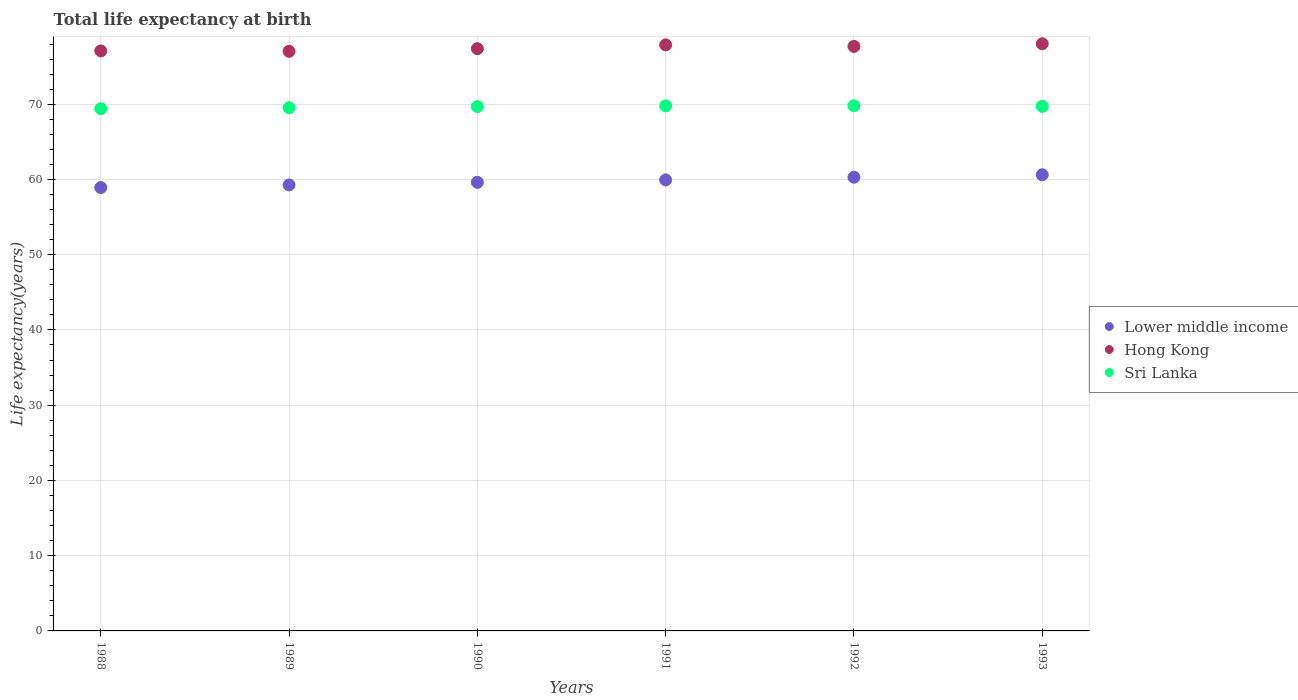Is the number of dotlines equal to the number of legend labels?
Provide a succinct answer. Yes. What is the life expectancy at birth in in Sri Lanka in 1990?
Your response must be concise. 69.68. Across all years, what is the maximum life expectancy at birth in in Hong Kong?
Keep it short and to the point. 78.03. Across all years, what is the minimum life expectancy at birth in in Hong Kong?
Your answer should be very brief. 77.03. In which year was the life expectancy at birth in in Sri Lanka maximum?
Your response must be concise. 1992. What is the total life expectancy at birth in in Lower middle income in the graph?
Your answer should be very brief. 358.67. What is the difference between the life expectancy at birth in in Lower middle income in 1989 and that in 1992?
Your response must be concise. -1.02. What is the difference between the life expectancy at birth in in Sri Lanka in 1991 and the life expectancy at birth in in Lower middle income in 1990?
Your answer should be compact. 10.16. What is the average life expectancy at birth in in Lower middle income per year?
Your answer should be very brief. 59.78. In the year 1988, what is the difference between the life expectancy at birth in in Sri Lanka and life expectancy at birth in in Hong Kong?
Make the answer very short. -7.68. What is the ratio of the life expectancy at birth in in Lower middle income in 1988 to that in 1992?
Ensure brevity in your answer.  0.98. What is the difference between the highest and the second highest life expectancy at birth in in Hong Kong?
Give a very brief answer. 0.15. What is the difference between the highest and the lowest life expectancy at birth in in Sri Lanka?
Offer a very short reply. 0.39. In how many years, is the life expectancy at birth in in Sri Lanka greater than the average life expectancy at birth in in Sri Lanka taken over all years?
Give a very brief answer. 4. Is the sum of the life expectancy at birth in in Hong Kong in 1989 and 1992 greater than the maximum life expectancy at birth in in Lower middle income across all years?
Give a very brief answer. Yes. Is it the case that in every year, the sum of the life expectancy at birth in in Hong Kong and life expectancy at birth in in Sri Lanka  is greater than the life expectancy at birth in in Lower middle income?
Your response must be concise. Yes. Does the life expectancy at birth in in Sri Lanka monotonically increase over the years?
Provide a succinct answer. No. Is the life expectancy at birth in in Sri Lanka strictly greater than the life expectancy at birth in in Lower middle income over the years?
Provide a short and direct response. Yes. Is the life expectancy at birth in in Hong Kong strictly less than the life expectancy at birth in in Sri Lanka over the years?
Your answer should be very brief. No. How many dotlines are there?
Keep it short and to the point. 3. How many years are there in the graph?
Your response must be concise. 6. Does the graph contain any zero values?
Offer a terse response. No. Does the graph contain grids?
Provide a short and direct response. Yes. How many legend labels are there?
Your answer should be compact. 3. What is the title of the graph?
Offer a very short reply. Total life expectancy at birth. Does "St. Martin (French part)" appear as one of the legend labels in the graph?
Your response must be concise. No. What is the label or title of the Y-axis?
Make the answer very short. Life expectancy(years). What is the Life expectancy(years) of Lower middle income in 1988?
Your response must be concise. 58.93. What is the Life expectancy(years) in Hong Kong in 1988?
Provide a short and direct response. 77.08. What is the Life expectancy(years) in Sri Lanka in 1988?
Make the answer very short. 69.4. What is the Life expectancy(years) of Lower middle income in 1989?
Ensure brevity in your answer.  59.27. What is the Life expectancy(years) in Hong Kong in 1989?
Your response must be concise. 77.03. What is the Life expectancy(years) in Sri Lanka in 1989?
Keep it short and to the point. 69.53. What is the Life expectancy(years) in Lower middle income in 1990?
Your answer should be very brief. 59.62. What is the Life expectancy(years) in Hong Kong in 1990?
Offer a terse response. 77.38. What is the Life expectancy(years) in Sri Lanka in 1990?
Make the answer very short. 69.68. What is the Life expectancy(years) of Lower middle income in 1991?
Your answer should be compact. 59.94. What is the Life expectancy(years) in Hong Kong in 1991?
Your answer should be very brief. 77.88. What is the Life expectancy(years) in Sri Lanka in 1991?
Make the answer very short. 69.78. What is the Life expectancy(years) in Lower middle income in 1992?
Your response must be concise. 60.29. What is the Life expectancy(years) of Hong Kong in 1992?
Offer a very short reply. 77.68. What is the Life expectancy(years) in Sri Lanka in 1992?
Your answer should be compact. 69.8. What is the Life expectancy(years) of Lower middle income in 1993?
Offer a very short reply. 60.62. What is the Life expectancy(years) in Hong Kong in 1993?
Make the answer very short. 78.03. What is the Life expectancy(years) in Sri Lanka in 1993?
Offer a very short reply. 69.72. Across all years, what is the maximum Life expectancy(years) in Lower middle income?
Offer a terse response. 60.62. Across all years, what is the maximum Life expectancy(years) of Hong Kong?
Your response must be concise. 78.03. Across all years, what is the maximum Life expectancy(years) in Sri Lanka?
Your answer should be compact. 69.8. Across all years, what is the minimum Life expectancy(years) in Lower middle income?
Make the answer very short. 58.93. Across all years, what is the minimum Life expectancy(years) of Hong Kong?
Provide a short and direct response. 77.03. Across all years, what is the minimum Life expectancy(years) in Sri Lanka?
Provide a short and direct response. 69.4. What is the total Life expectancy(years) of Lower middle income in the graph?
Offer a very short reply. 358.67. What is the total Life expectancy(years) in Hong Kong in the graph?
Keep it short and to the point. 465.09. What is the total Life expectancy(years) of Sri Lanka in the graph?
Your answer should be very brief. 417.91. What is the difference between the Life expectancy(years) of Lower middle income in 1988 and that in 1989?
Your response must be concise. -0.35. What is the difference between the Life expectancy(years) in Hong Kong in 1988 and that in 1989?
Keep it short and to the point. 0.05. What is the difference between the Life expectancy(years) in Sri Lanka in 1988 and that in 1989?
Provide a short and direct response. -0.13. What is the difference between the Life expectancy(years) in Lower middle income in 1988 and that in 1990?
Provide a succinct answer. -0.69. What is the difference between the Life expectancy(years) of Hong Kong in 1988 and that in 1990?
Provide a succinct answer. -0.3. What is the difference between the Life expectancy(years) of Sri Lanka in 1988 and that in 1990?
Ensure brevity in your answer.  -0.28. What is the difference between the Life expectancy(years) of Lower middle income in 1988 and that in 1991?
Your response must be concise. -1.01. What is the difference between the Life expectancy(years) of Sri Lanka in 1988 and that in 1991?
Your answer should be compact. -0.38. What is the difference between the Life expectancy(years) in Lower middle income in 1988 and that in 1992?
Ensure brevity in your answer.  -1.37. What is the difference between the Life expectancy(years) of Hong Kong in 1988 and that in 1992?
Make the answer very short. -0.6. What is the difference between the Life expectancy(years) in Sri Lanka in 1988 and that in 1992?
Ensure brevity in your answer.  -0.39. What is the difference between the Life expectancy(years) in Lower middle income in 1988 and that in 1993?
Your answer should be compact. -1.7. What is the difference between the Life expectancy(years) in Hong Kong in 1988 and that in 1993?
Your response must be concise. -0.95. What is the difference between the Life expectancy(years) of Sri Lanka in 1988 and that in 1993?
Offer a very short reply. -0.31. What is the difference between the Life expectancy(years) in Lower middle income in 1989 and that in 1990?
Make the answer very short. -0.34. What is the difference between the Life expectancy(years) in Hong Kong in 1989 and that in 1990?
Keep it short and to the point. -0.35. What is the difference between the Life expectancy(years) of Sri Lanka in 1989 and that in 1990?
Your answer should be compact. -0.15. What is the difference between the Life expectancy(years) in Lower middle income in 1989 and that in 1991?
Make the answer very short. -0.66. What is the difference between the Life expectancy(years) of Hong Kong in 1989 and that in 1991?
Offer a terse response. -0.85. What is the difference between the Life expectancy(years) in Sri Lanka in 1989 and that in 1991?
Your response must be concise. -0.25. What is the difference between the Life expectancy(years) of Lower middle income in 1989 and that in 1992?
Keep it short and to the point. -1.02. What is the difference between the Life expectancy(years) in Hong Kong in 1989 and that in 1992?
Offer a very short reply. -0.65. What is the difference between the Life expectancy(years) in Sri Lanka in 1989 and that in 1992?
Provide a short and direct response. -0.26. What is the difference between the Life expectancy(years) of Lower middle income in 1989 and that in 1993?
Ensure brevity in your answer.  -1.35. What is the difference between the Life expectancy(years) in Hong Kong in 1989 and that in 1993?
Offer a terse response. -1. What is the difference between the Life expectancy(years) in Sri Lanka in 1989 and that in 1993?
Offer a very short reply. -0.18. What is the difference between the Life expectancy(years) of Lower middle income in 1990 and that in 1991?
Offer a terse response. -0.32. What is the difference between the Life expectancy(years) in Hong Kong in 1990 and that in 1991?
Make the answer very short. -0.5. What is the difference between the Life expectancy(years) of Sri Lanka in 1990 and that in 1991?
Provide a succinct answer. -0.1. What is the difference between the Life expectancy(years) of Lower middle income in 1990 and that in 1992?
Ensure brevity in your answer.  -0.67. What is the difference between the Life expectancy(years) in Hong Kong in 1990 and that in 1992?
Your answer should be very brief. -0.3. What is the difference between the Life expectancy(years) in Sri Lanka in 1990 and that in 1992?
Make the answer very short. -0.12. What is the difference between the Life expectancy(years) in Lower middle income in 1990 and that in 1993?
Your answer should be very brief. -1. What is the difference between the Life expectancy(years) in Hong Kong in 1990 and that in 1993?
Provide a short and direct response. -0.65. What is the difference between the Life expectancy(years) of Sri Lanka in 1990 and that in 1993?
Give a very brief answer. -0.04. What is the difference between the Life expectancy(years) of Lower middle income in 1991 and that in 1992?
Ensure brevity in your answer.  -0.36. What is the difference between the Life expectancy(years) of Hong Kong in 1991 and that in 1992?
Your answer should be compact. 0.2. What is the difference between the Life expectancy(years) in Sri Lanka in 1991 and that in 1992?
Offer a very short reply. -0.02. What is the difference between the Life expectancy(years) of Lower middle income in 1991 and that in 1993?
Offer a very short reply. -0.68. What is the difference between the Life expectancy(years) of Hong Kong in 1991 and that in 1993?
Your answer should be very brief. -0.15. What is the difference between the Life expectancy(years) in Sri Lanka in 1991 and that in 1993?
Provide a short and direct response. 0.06. What is the difference between the Life expectancy(years) of Lower middle income in 1992 and that in 1993?
Your response must be concise. -0.33. What is the difference between the Life expectancy(years) in Hong Kong in 1992 and that in 1993?
Keep it short and to the point. -0.35. What is the difference between the Life expectancy(years) in Sri Lanka in 1992 and that in 1993?
Your response must be concise. 0.08. What is the difference between the Life expectancy(years) of Lower middle income in 1988 and the Life expectancy(years) of Hong Kong in 1989?
Provide a succinct answer. -18.1. What is the difference between the Life expectancy(years) in Lower middle income in 1988 and the Life expectancy(years) in Sri Lanka in 1989?
Keep it short and to the point. -10.61. What is the difference between the Life expectancy(years) in Hong Kong in 1988 and the Life expectancy(years) in Sri Lanka in 1989?
Ensure brevity in your answer.  7.55. What is the difference between the Life expectancy(years) of Lower middle income in 1988 and the Life expectancy(years) of Hong Kong in 1990?
Keep it short and to the point. -18.45. What is the difference between the Life expectancy(years) of Lower middle income in 1988 and the Life expectancy(years) of Sri Lanka in 1990?
Provide a short and direct response. -10.75. What is the difference between the Life expectancy(years) in Hong Kong in 1988 and the Life expectancy(years) in Sri Lanka in 1990?
Offer a terse response. 7.4. What is the difference between the Life expectancy(years) in Lower middle income in 1988 and the Life expectancy(years) in Hong Kong in 1991?
Make the answer very short. -18.96. What is the difference between the Life expectancy(years) of Lower middle income in 1988 and the Life expectancy(years) of Sri Lanka in 1991?
Make the answer very short. -10.85. What is the difference between the Life expectancy(years) in Hong Kong in 1988 and the Life expectancy(years) in Sri Lanka in 1991?
Make the answer very short. 7.3. What is the difference between the Life expectancy(years) of Lower middle income in 1988 and the Life expectancy(years) of Hong Kong in 1992?
Offer a terse response. -18.75. What is the difference between the Life expectancy(years) in Lower middle income in 1988 and the Life expectancy(years) in Sri Lanka in 1992?
Offer a very short reply. -10.87. What is the difference between the Life expectancy(years) in Hong Kong in 1988 and the Life expectancy(years) in Sri Lanka in 1992?
Ensure brevity in your answer.  7.29. What is the difference between the Life expectancy(years) in Lower middle income in 1988 and the Life expectancy(years) in Hong Kong in 1993?
Provide a short and direct response. -19.11. What is the difference between the Life expectancy(years) of Lower middle income in 1988 and the Life expectancy(years) of Sri Lanka in 1993?
Give a very brief answer. -10.79. What is the difference between the Life expectancy(years) in Hong Kong in 1988 and the Life expectancy(years) in Sri Lanka in 1993?
Your answer should be very brief. 7.37. What is the difference between the Life expectancy(years) of Lower middle income in 1989 and the Life expectancy(years) of Hong Kong in 1990?
Provide a short and direct response. -18.11. What is the difference between the Life expectancy(years) in Lower middle income in 1989 and the Life expectancy(years) in Sri Lanka in 1990?
Your answer should be compact. -10.41. What is the difference between the Life expectancy(years) of Hong Kong in 1989 and the Life expectancy(years) of Sri Lanka in 1990?
Provide a succinct answer. 7.35. What is the difference between the Life expectancy(years) in Lower middle income in 1989 and the Life expectancy(years) in Hong Kong in 1991?
Ensure brevity in your answer.  -18.61. What is the difference between the Life expectancy(years) in Lower middle income in 1989 and the Life expectancy(years) in Sri Lanka in 1991?
Provide a succinct answer. -10.51. What is the difference between the Life expectancy(years) of Hong Kong in 1989 and the Life expectancy(years) of Sri Lanka in 1991?
Give a very brief answer. 7.25. What is the difference between the Life expectancy(years) in Lower middle income in 1989 and the Life expectancy(years) in Hong Kong in 1992?
Provide a short and direct response. -18.4. What is the difference between the Life expectancy(years) of Lower middle income in 1989 and the Life expectancy(years) of Sri Lanka in 1992?
Give a very brief answer. -10.52. What is the difference between the Life expectancy(years) in Hong Kong in 1989 and the Life expectancy(years) in Sri Lanka in 1992?
Offer a very short reply. 7.23. What is the difference between the Life expectancy(years) in Lower middle income in 1989 and the Life expectancy(years) in Hong Kong in 1993?
Give a very brief answer. -18.76. What is the difference between the Life expectancy(years) of Lower middle income in 1989 and the Life expectancy(years) of Sri Lanka in 1993?
Make the answer very short. -10.44. What is the difference between the Life expectancy(years) in Hong Kong in 1989 and the Life expectancy(years) in Sri Lanka in 1993?
Provide a short and direct response. 7.31. What is the difference between the Life expectancy(years) of Lower middle income in 1990 and the Life expectancy(years) of Hong Kong in 1991?
Ensure brevity in your answer.  -18.26. What is the difference between the Life expectancy(years) in Lower middle income in 1990 and the Life expectancy(years) in Sri Lanka in 1991?
Provide a succinct answer. -10.16. What is the difference between the Life expectancy(years) in Hong Kong in 1990 and the Life expectancy(years) in Sri Lanka in 1991?
Your response must be concise. 7.6. What is the difference between the Life expectancy(years) of Lower middle income in 1990 and the Life expectancy(years) of Hong Kong in 1992?
Give a very brief answer. -18.06. What is the difference between the Life expectancy(years) in Lower middle income in 1990 and the Life expectancy(years) in Sri Lanka in 1992?
Provide a succinct answer. -10.18. What is the difference between the Life expectancy(years) in Hong Kong in 1990 and the Life expectancy(years) in Sri Lanka in 1992?
Your answer should be very brief. 7.58. What is the difference between the Life expectancy(years) in Lower middle income in 1990 and the Life expectancy(years) in Hong Kong in 1993?
Your answer should be compact. -18.41. What is the difference between the Life expectancy(years) in Lower middle income in 1990 and the Life expectancy(years) in Sri Lanka in 1993?
Give a very brief answer. -10.1. What is the difference between the Life expectancy(years) in Hong Kong in 1990 and the Life expectancy(years) in Sri Lanka in 1993?
Offer a terse response. 7.66. What is the difference between the Life expectancy(years) in Lower middle income in 1991 and the Life expectancy(years) in Hong Kong in 1992?
Make the answer very short. -17.74. What is the difference between the Life expectancy(years) of Lower middle income in 1991 and the Life expectancy(years) of Sri Lanka in 1992?
Keep it short and to the point. -9.86. What is the difference between the Life expectancy(years) in Hong Kong in 1991 and the Life expectancy(years) in Sri Lanka in 1992?
Ensure brevity in your answer.  8.09. What is the difference between the Life expectancy(years) in Lower middle income in 1991 and the Life expectancy(years) in Hong Kong in 1993?
Your response must be concise. -18.09. What is the difference between the Life expectancy(years) of Lower middle income in 1991 and the Life expectancy(years) of Sri Lanka in 1993?
Offer a terse response. -9.78. What is the difference between the Life expectancy(years) in Hong Kong in 1991 and the Life expectancy(years) in Sri Lanka in 1993?
Provide a short and direct response. 8.17. What is the difference between the Life expectancy(years) of Lower middle income in 1992 and the Life expectancy(years) of Hong Kong in 1993?
Give a very brief answer. -17.74. What is the difference between the Life expectancy(years) of Lower middle income in 1992 and the Life expectancy(years) of Sri Lanka in 1993?
Your answer should be very brief. -9.42. What is the difference between the Life expectancy(years) in Hong Kong in 1992 and the Life expectancy(years) in Sri Lanka in 1993?
Offer a terse response. 7.96. What is the average Life expectancy(years) of Lower middle income per year?
Provide a succinct answer. 59.78. What is the average Life expectancy(years) of Hong Kong per year?
Provide a short and direct response. 77.51. What is the average Life expectancy(years) in Sri Lanka per year?
Your answer should be very brief. 69.65. In the year 1988, what is the difference between the Life expectancy(years) of Lower middle income and Life expectancy(years) of Hong Kong?
Provide a succinct answer. -18.16. In the year 1988, what is the difference between the Life expectancy(years) in Lower middle income and Life expectancy(years) in Sri Lanka?
Keep it short and to the point. -10.48. In the year 1988, what is the difference between the Life expectancy(years) of Hong Kong and Life expectancy(years) of Sri Lanka?
Ensure brevity in your answer.  7.68. In the year 1989, what is the difference between the Life expectancy(years) in Lower middle income and Life expectancy(years) in Hong Kong?
Your response must be concise. -17.75. In the year 1989, what is the difference between the Life expectancy(years) in Lower middle income and Life expectancy(years) in Sri Lanka?
Keep it short and to the point. -10.26. In the year 1989, what is the difference between the Life expectancy(years) of Hong Kong and Life expectancy(years) of Sri Lanka?
Your answer should be compact. 7.49. In the year 1990, what is the difference between the Life expectancy(years) in Lower middle income and Life expectancy(years) in Hong Kong?
Offer a very short reply. -17.76. In the year 1990, what is the difference between the Life expectancy(years) of Lower middle income and Life expectancy(years) of Sri Lanka?
Offer a terse response. -10.06. In the year 1990, what is the difference between the Life expectancy(years) in Hong Kong and Life expectancy(years) in Sri Lanka?
Keep it short and to the point. 7.7. In the year 1991, what is the difference between the Life expectancy(years) of Lower middle income and Life expectancy(years) of Hong Kong?
Offer a very short reply. -17.95. In the year 1991, what is the difference between the Life expectancy(years) of Lower middle income and Life expectancy(years) of Sri Lanka?
Your answer should be very brief. -9.84. In the year 1991, what is the difference between the Life expectancy(years) of Hong Kong and Life expectancy(years) of Sri Lanka?
Your answer should be compact. 8.1. In the year 1992, what is the difference between the Life expectancy(years) in Lower middle income and Life expectancy(years) in Hong Kong?
Provide a succinct answer. -17.39. In the year 1992, what is the difference between the Life expectancy(years) in Lower middle income and Life expectancy(years) in Sri Lanka?
Provide a short and direct response. -9.5. In the year 1992, what is the difference between the Life expectancy(years) of Hong Kong and Life expectancy(years) of Sri Lanka?
Give a very brief answer. 7.88. In the year 1993, what is the difference between the Life expectancy(years) of Lower middle income and Life expectancy(years) of Hong Kong?
Offer a very short reply. -17.41. In the year 1993, what is the difference between the Life expectancy(years) in Lower middle income and Life expectancy(years) in Sri Lanka?
Your response must be concise. -9.1. In the year 1993, what is the difference between the Life expectancy(years) in Hong Kong and Life expectancy(years) in Sri Lanka?
Your answer should be compact. 8.31. What is the ratio of the Life expectancy(years) in Lower middle income in 1988 to that in 1989?
Offer a terse response. 0.99. What is the ratio of the Life expectancy(years) of Lower middle income in 1988 to that in 1990?
Offer a terse response. 0.99. What is the ratio of the Life expectancy(years) of Hong Kong in 1988 to that in 1990?
Your answer should be very brief. 1. What is the ratio of the Life expectancy(years) in Sri Lanka in 1988 to that in 1990?
Give a very brief answer. 1. What is the ratio of the Life expectancy(years) of Lower middle income in 1988 to that in 1991?
Keep it short and to the point. 0.98. What is the ratio of the Life expectancy(years) of Hong Kong in 1988 to that in 1991?
Provide a succinct answer. 0.99. What is the ratio of the Life expectancy(years) of Sri Lanka in 1988 to that in 1991?
Give a very brief answer. 0.99. What is the ratio of the Life expectancy(years) of Lower middle income in 1988 to that in 1992?
Your response must be concise. 0.98. What is the ratio of the Life expectancy(years) in Lower middle income in 1988 to that in 1993?
Your answer should be very brief. 0.97. What is the ratio of the Life expectancy(years) in Lower middle income in 1989 to that in 1990?
Offer a very short reply. 0.99. What is the ratio of the Life expectancy(years) of Hong Kong in 1989 to that in 1990?
Your response must be concise. 1. What is the ratio of the Life expectancy(years) of Sri Lanka in 1989 to that in 1990?
Give a very brief answer. 1. What is the ratio of the Life expectancy(years) of Lower middle income in 1989 to that in 1991?
Your answer should be very brief. 0.99. What is the ratio of the Life expectancy(years) in Sri Lanka in 1989 to that in 1991?
Provide a short and direct response. 1. What is the ratio of the Life expectancy(years) of Lower middle income in 1989 to that in 1992?
Give a very brief answer. 0.98. What is the ratio of the Life expectancy(years) of Hong Kong in 1989 to that in 1992?
Keep it short and to the point. 0.99. What is the ratio of the Life expectancy(years) of Sri Lanka in 1989 to that in 1992?
Your answer should be compact. 1. What is the ratio of the Life expectancy(years) of Lower middle income in 1989 to that in 1993?
Make the answer very short. 0.98. What is the ratio of the Life expectancy(years) of Hong Kong in 1989 to that in 1993?
Keep it short and to the point. 0.99. What is the ratio of the Life expectancy(years) of Lower middle income in 1990 to that in 1991?
Your response must be concise. 0.99. What is the ratio of the Life expectancy(years) of Sri Lanka in 1990 to that in 1991?
Make the answer very short. 1. What is the ratio of the Life expectancy(years) in Hong Kong in 1990 to that in 1992?
Ensure brevity in your answer.  1. What is the ratio of the Life expectancy(years) in Sri Lanka in 1990 to that in 1992?
Ensure brevity in your answer.  1. What is the ratio of the Life expectancy(years) of Lower middle income in 1990 to that in 1993?
Your response must be concise. 0.98. What is the ratio of the Life expectancy(years) of Sri Lanka in 1990 to that in 1993?
Offer a terse response. 1. What is the ratio of the Life expectancy(years) in Lower middle income in 1991 to that in 1992?
Provide a succinct answer. 0.99. What is the ratio of the Life expectancy(years) of Lower middle income in 1991 to that in 1993?
Offer a very short reply. 0.99. What is the ratio of the Life expectancy(years) of Sri Lanka in 1991 to that in 1993?
Provide a succinct answer. 1. What is the ratio of the Life expectancy(years) in Hong Kong in 1992 to that in 1993?
Give a very brief answer. 1. What is the difference between the highest and the second highest Life expectancy(years) in Lower middle income?
Provide a short and direct response. 0.33. What is the difference between the highest and the second highest Life expectancy(years) of Hong Kong?
Make the answer very short. 0.15. What is the difference between the highest and the second highest Life expectancy(years) in Sri Lanka?
Your response must be concise. 0.02. What is the difference between the highest and the lowest Life expectancy(years) of Lower middle income?
Make the answer very short. 1.7. What is the difference between the highest and the lowest Life expectancy(years) of Sri Lanka?
Your answer should be compact. 0.39. 